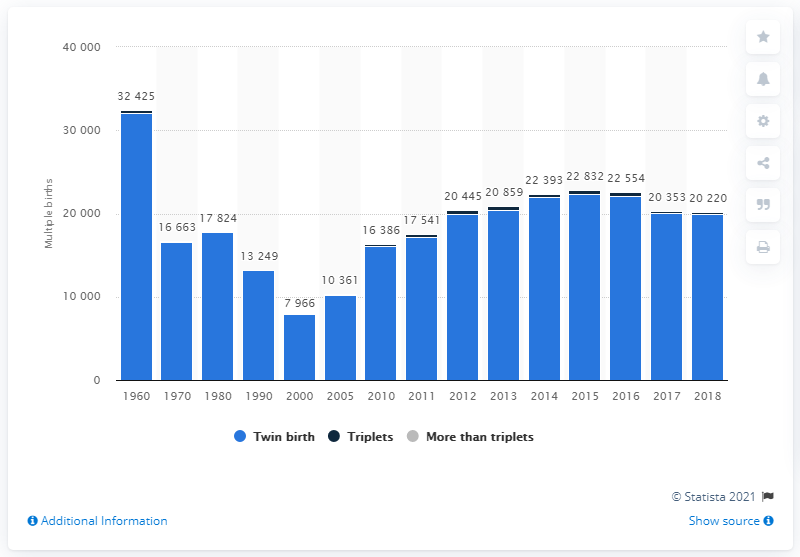List a handful of essential elements in this visual. There were 32,126 twin births in Russia in 1960. In 2018, there were 19,898 twin births among Russian women. In 2000, the minimum number of twin births in Russia was 7,870. 